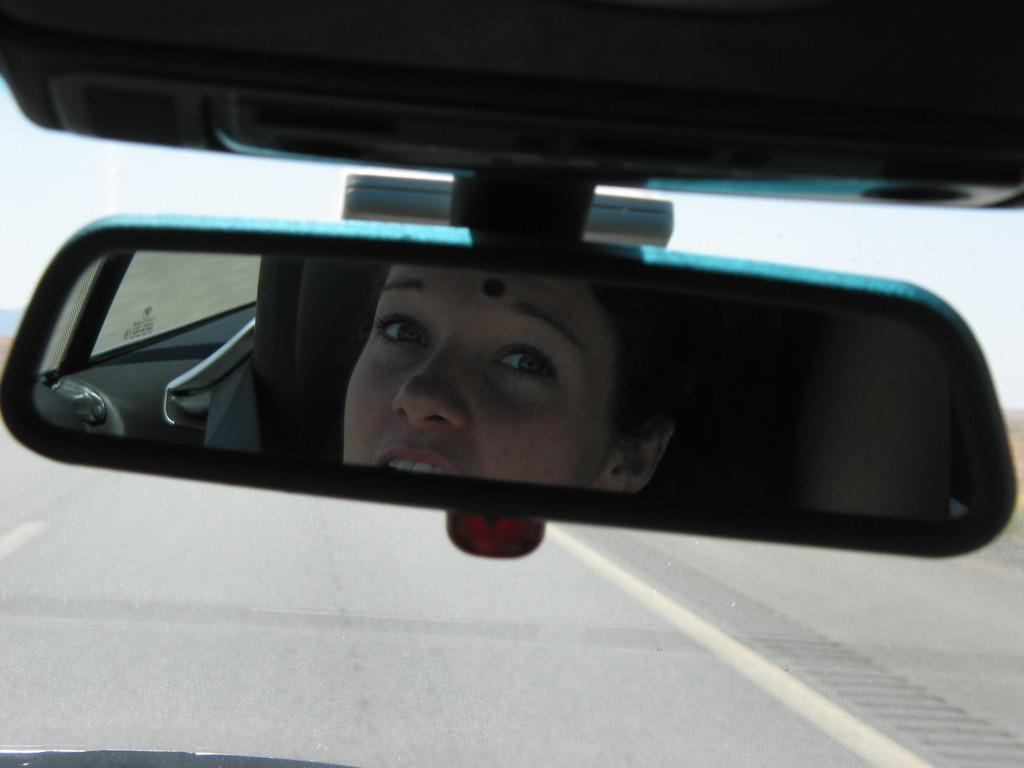What object in the image reflects an image? There is a mirror in the image that reflects a woman's face. What can be seen in the mirror's reflection? The mirror reflects a woman's face. What is visible in the background of the image? There is a road visible in the background of the image. How many beginner dolls are sitting on the road in the image? There are no dolls present in the image, let alone beginner dolls on the road. 